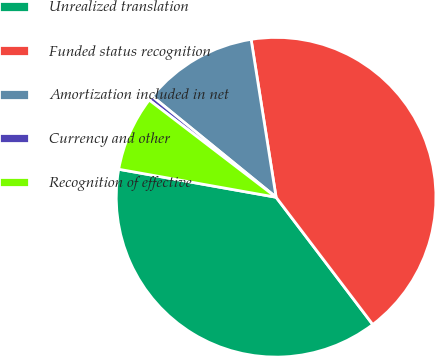<chart> <loc_0><loc_0><loc_500><loc_500><pie_chart><fcel>Unrealized translation<fcel>Funded status recognition<fcel>Amortization included in net<fcel>Currency and other<fcel>Recognition of effective<nl><fcel>38.14%<fcel>42.16%<fcel>11.62%<fcel>0.48%<fcel>7.6%<nl></chart> 